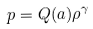Convert formula to latex. <formula><loc_0><loc_0><loc_500><loc_500>p = Q ( a ) \rho ^ { \gamma }</formula> 